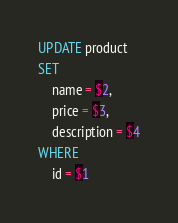<code> <loc_0><loc_0><loc_500><loc_500><_SQL_>UPDATE product
SET
    name = $2,
    price = $3,
    description = $4
WHERE
    id = $1
</code> 